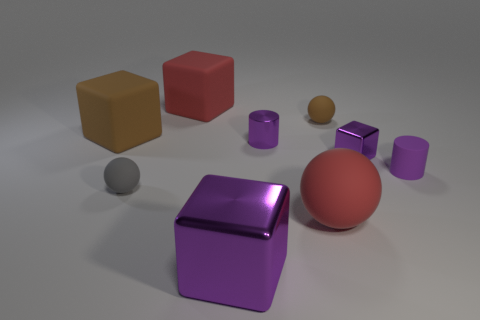Subtract 2 cubes. How many cubes are left? 2 Subtract all big red rubber blocks. How many blocks are left? 3 Add 1 tiny blue rubber objects. How many objects exist? 10 Subtract all yellow cubes. Subtract all yellow spheres. How many cubes are left? 4 Subtract all cubes. How many objects are left? 5 Subtract all large cyan balls. Subtract all big red rubber objects. How many objects are left? 7 Add 3 small brown balls. How many small brown balls are left? 4 Add 6 purple matte cylinders. How many purple matte cylinders exist? 7 Subtract 1 gray spheres. How many objects are left? 8 